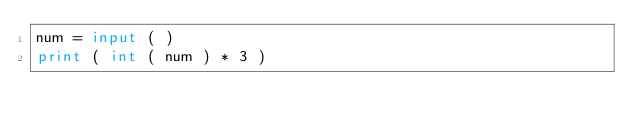Convert code to text. <code><loc_0><loc_0><loc_500><loc_500><_Python_>num = input ( )
print ( int ( num ) * 3 )</code> 